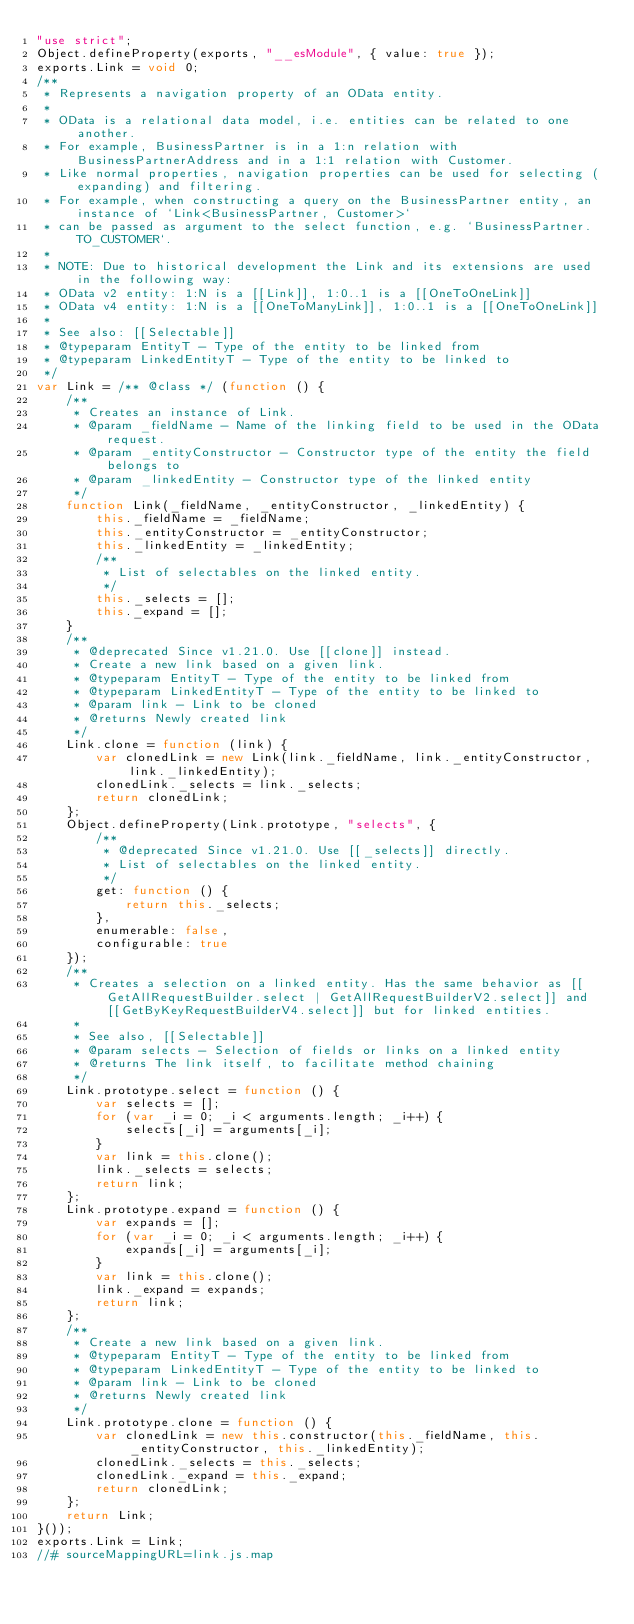Convert code to text. <code><loc_0><loc_0><loc_500><loc_500><_JavaScript_>"use strict";
Object.defineProperty(exports, "__esModule", { value: true });
exports.Link = void 0;
/**
 * Represents a navigation property of an OData entity.
 *
 * OData is a relational data model, i.e. entities can be related to one another.
 * For example, BusinessPartner is in a 1:n relation with BusinessPartnerAddress and in a 1:1 relation with Customer.
 * Like normal properties, navigation properties can be used for selecting (expanding) and filtering.
 * For example, when constructing a query on the BusinessPartner entity, an instance of `Link<BusinessPartner, Customer>`
 * can be passed as argument to the select function, e.g. `BusinessPartner.TO_CUSTOMER`.
 *
 * NOTE: Due to historical development the Link and its extensions are used in the following way:
 * OData v2 entity: 1:N is a [[Link]], 1:0..1 is a [[OneToOneLink]]
 * OData v4 entity: 1:N is a [[OneToManyLink]], 1:0..1 is a [[OneToOneLink]]
 *
 * See also: [[Selectable]]
 * @typeparam EntityT - Type of the entity to be linked from
 * @typeparam LinkedEntityT - Type of the entity to be linked to
 */
var Link = /** @class */ (function () {
    /**
     * Creates an instance of Link.
     * @param _fieldName - Name of the linking field to be used in the OData request.
     * @param _entityConstructor - Constructor type of the entity the field belongs to
     * @param _linkedEntity - Constructor type of the linked entity
     */
    function Link(_fieldName, _entityConstructor, _linkedEntity) {
        this._fieldName = _fieldName;
        this._entityConstructor = _entityConstructor;
        this._linkedEntity = _linkedEntity;
        /**
         * List of selectables on the linked entity.
         */
        this._selects = [];
        this._expand = [];
    }
    /**
     * @deprecated Since v1.21.0. Use [[clone]] instead.
     * Create a new link based on a given link.
     * @typeparam EntityT - Type of the entity to be linked from
     * @typeparam LinkedEntityT - Type of the entity to be linked to
     * @param link - Link to be cloned
     * @returns Newly created link
     */
    Link.clone = function (link) {
        var clonedLink = new Link(link._fieldName, link._entityConstructor, link._linkedEntity);
        clonedLink._selects = link._selects;
        return clonedLink;
    };
    Object.defineProperty(Link.prototype, "selects", {
        /**
         * @deprecated Since v1.21.0. Use [[_selects]] directly.
         * List of selectables on the linked entity.
         */
        get: function () {
            return this._selects;
        },
        enumerable: false,
        configurable: true
    });
    /**
     * Creates a selection on a linked entity. Has the same behavior as [[GetAllRequestBuilder.select | GetAllRequestBuilderV2.select]] and [[GetByKeyRequestBuilderV4.select]] but for linked entities.
     *
     * See also, [[Selectable]]
     * @param selects - Selection of fields or links on a linked entity
     * @returns The link itself, to facilitate method chaining
     */
    Link.prototype.select = function () {
        var selects = [];
        for (var _i = 0; _i < arguments.length; _i++) {
            selects[_i] = arguments[_i];
        }
        var link = this.clone();
        link._selects = selects;
        return link;
    };
    Link.prototype.expand = function () {
        var expands = [];
        for (var _i = 0; _i < arguments.length; _i++) {
            expands[_i] = arguments[_i];
        }
        var link = this.clone();
        link._expand = expands;
        return link;
    };
    /**
     * Create a new link based on a given link.
     * @typeparam EntityT - Type of the entity to be linked from
     * @typeparam LinkedEntityT - Type of the entity to be linked to
     * @param link - Link to be cloned
     * @returns Newly created link
     */
    Link.prototype.clone = function () {
        var clonedLink = new this.constructor(this._fieldName, this._entityConstructor, this._linkedEntity);
        clonedLink._selects = this._selects;
        clonedLink._expand = this._expand;
        return clonedLink;
    };
    return Link;
}());
exports.Link = Link;
//# sourceMappingURL=link.js.map</code> 